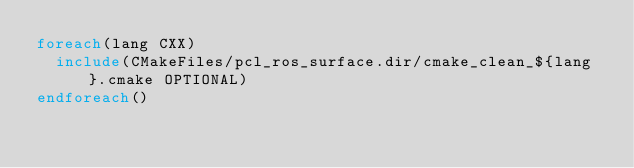Convert code to text. <code><loc_0><loc_0><loc_500><loc_500><_CMake_>foreach(lang CXX)
  include(CMakeFiles/pcl_ros_surface.dir/cmake_clean_${lang}.cmake OPTIONAL)
endforeach()
</code> 